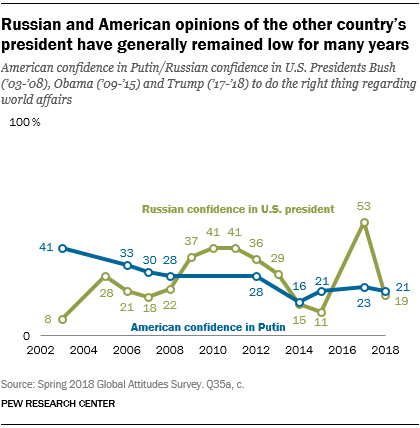List a handful of essential elements in this visual. Is the sum of the two leftmost values of the blue graph greater than 90? No. The color of a graph with the rightmost value of 19 is green. 